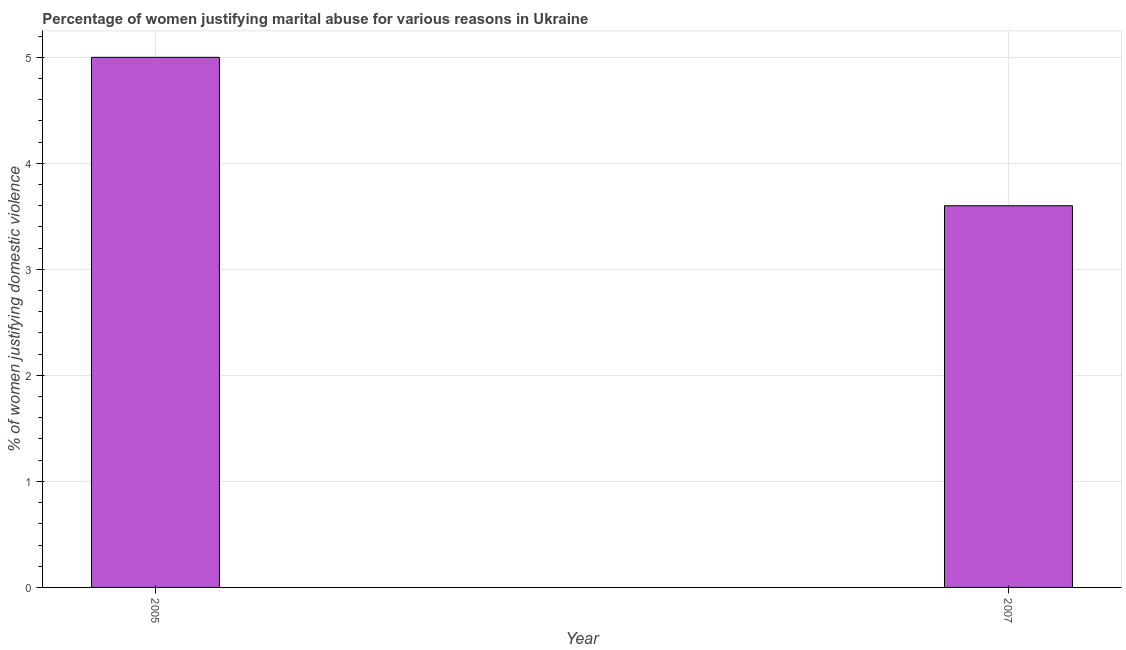Does the graph contain any zero values?
Make the answer very short. No. Does the graph contain grids?
Your answer should be compact. Yes. What is the title of the graph?
Provide a succinct answer. Percentage of women justifying marital abuse for various reasons in Ukraine. What is the label or title of the X-axis?
Ensure brevity in your answer.  Year. What is the label or title of the Y-axis?
Provide a short and direct response. % of women justifying domestic violence. Across all years, what is the maximum percentage of women justifying marital abuse?
Your answer should be very brief. 5. What is the sum of the percentage of women justifying marital abuse?
Keep it short and to the point. 8.6. What is the median percentage of women justifying marital abuse?
Give a very brief answer. 4.3. What is the ratio of the percentage of women justifying marital abuse in 2005 to that in 2007?
Offer a very short reply. 1.39. In how many years, is the percentage of women justifying marital abuse greater than the average percentage of women justifying marital abuse taken over all years?
Provide a succinct answer. 1. How many years are there in the graph?
Your response must be concise. 2. What is the difference between two consecutive major ticks on the Y-axis?
Keep it short and to the point. 1. Are the values on the major ticks of Y-axis written in scientific E-notation?
Make the answer very short. No. What is the % of women justifying domestic violence of 2005?
Provide a short and direct response. 5. What is the difference between the % of women justifying domestic violence in 2005 and 2007?
Provide a short and direct response. 1.4. What is the ratio of the % of women justifying domestic violence in 2005 to that in 2007?
Give a very brief answer. 1.39. 